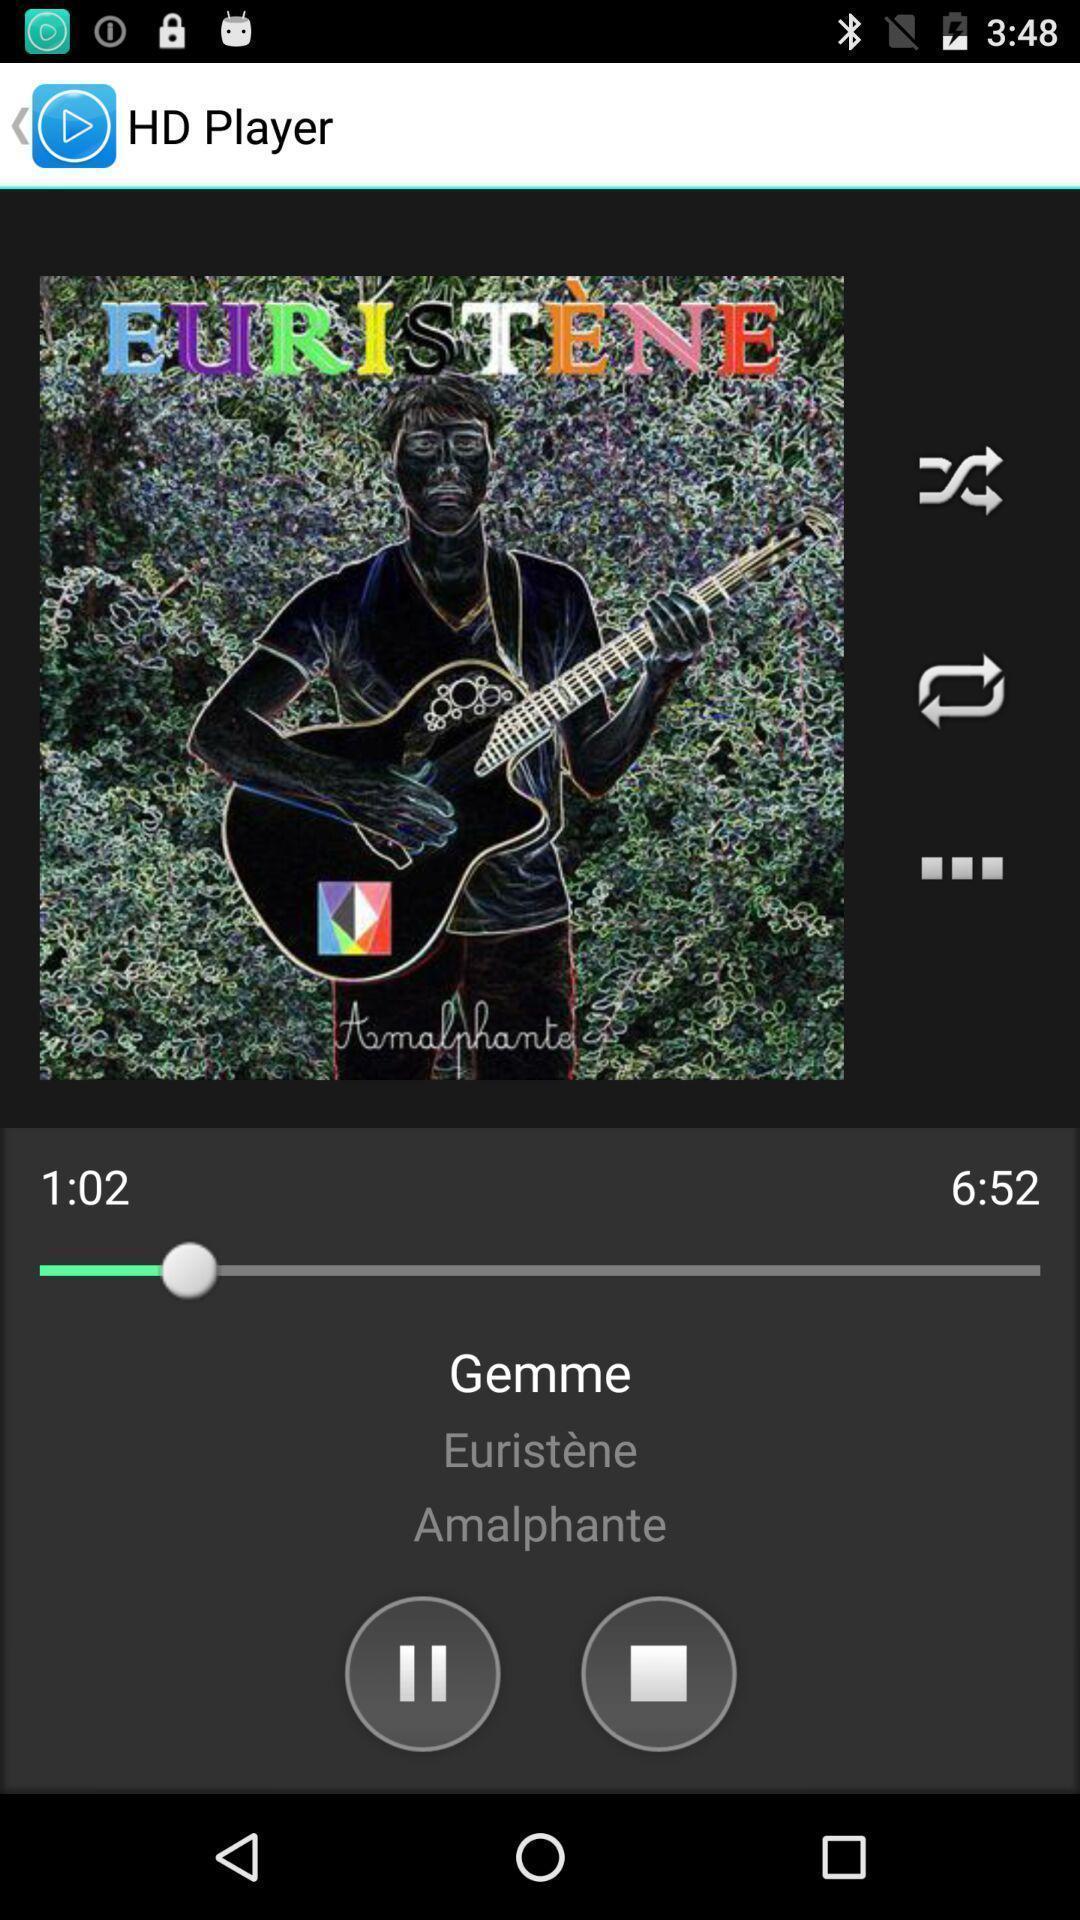Provide a description of this screenshot. Screen displaying the music app. 